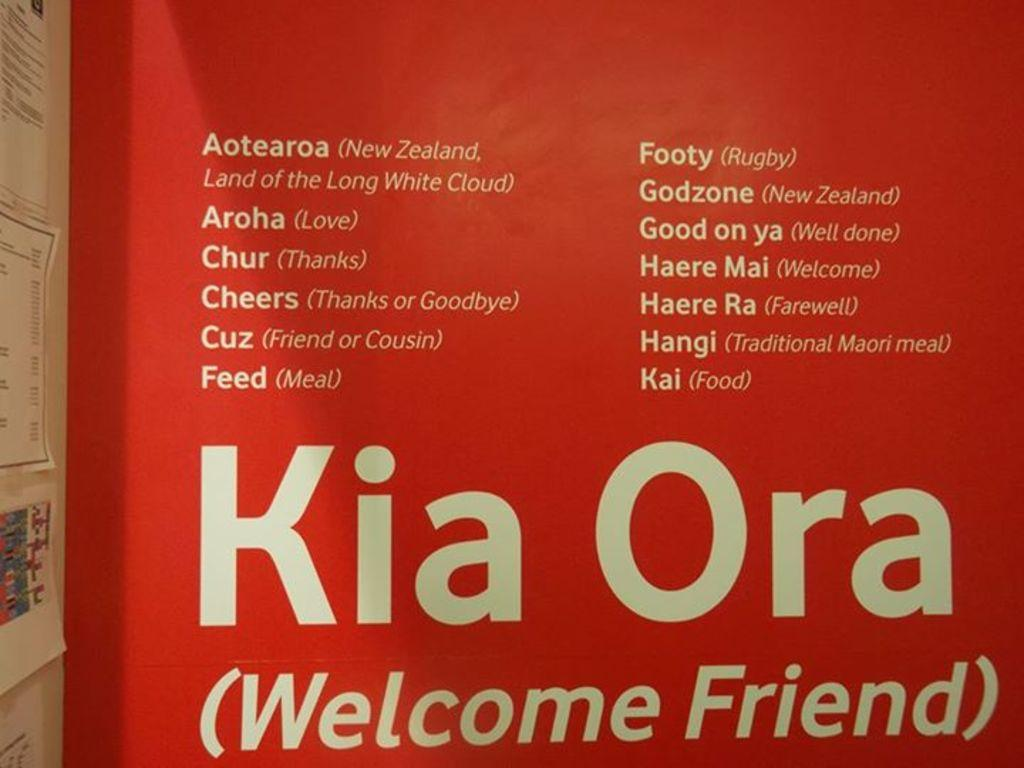<image>
Create a compact narrative representing the image presented. The translation for kia ora is welcome friend. 